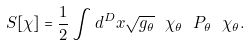<formula> <loc_0><loc_0><loc_500><loc_500>S [ \chi ] = { \frac { 1 } { 2 } } \int d ^ { D } x \sqrt { g _ { \theta } } \ \chi _ { \theta } \ P _ { \theta } \ \chi _ { \theta } .</formula> 